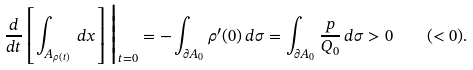<formula> <loc_0><loc_0><loc_500><loc_500>\frac { d } { d t } \left [ \int _ { A _ { \rho ( t ) } } \, d x \right ] \Big | _ { t = 0 } = - \int _ { \partial A _ { 0 } } \rho ^ { \prime } ( 0 ) \, d \sigma = \int _ { \partial A _ { 0 } } \frac { p } { Q _ { 0 } } \, d \sigma > 0 \quad ( < 0 ) .</formula> 